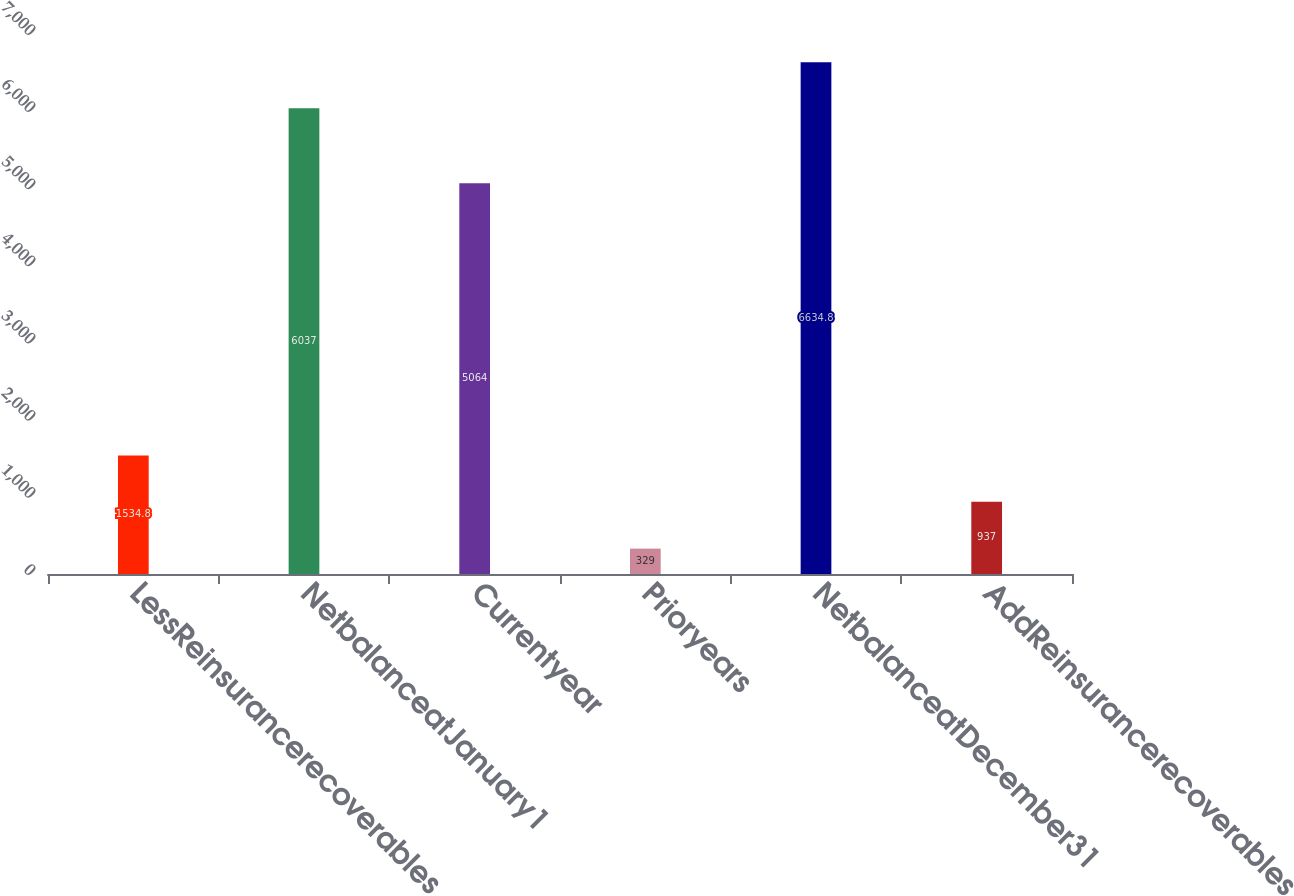Convert chart. <chart><loc_0><loc_0><loc_500><loc_500><bar_chart><fcel>LessReinsurancerecoverables<fcel>NetbalanceatJanuary1<fcel>Currentyear<fcel>Prioryears<fcel>NetbalanceatDecember31<fcel>AddReinsurancerecoverables<nl><fcel>1534.8<fcel>6037<fcel>5064<fcel>329<fcel>6634.8<fcel>937<nl></chart> 